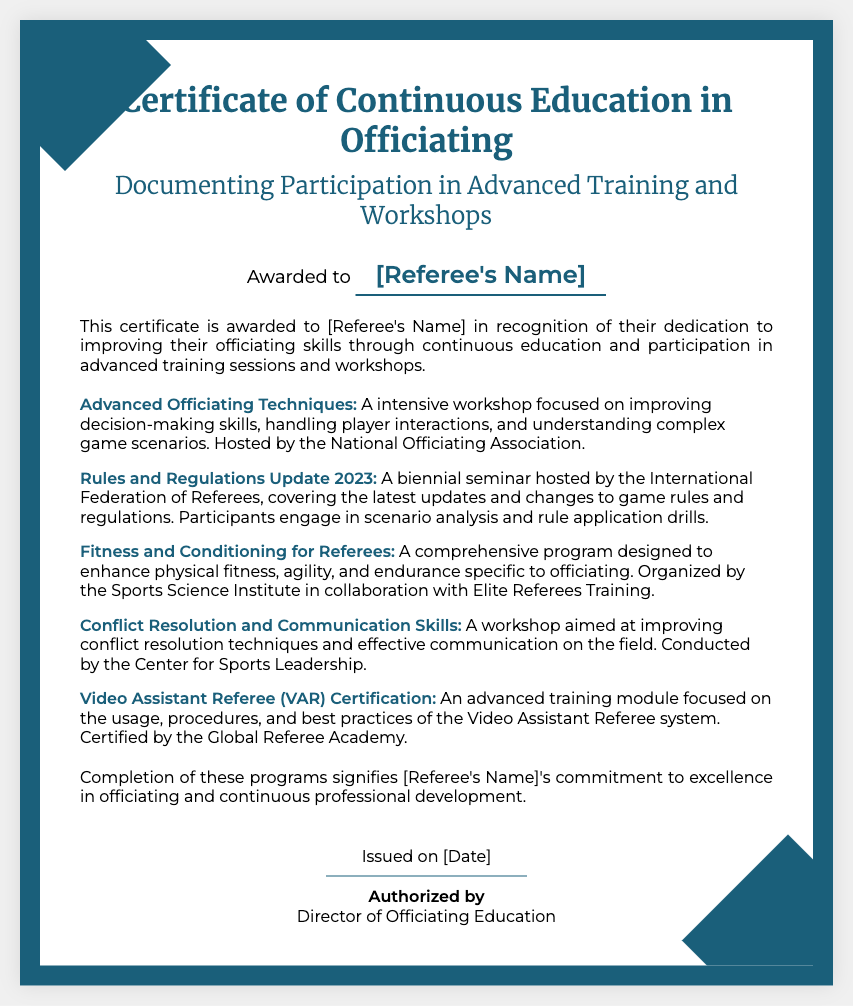What is the title of the certificate? The title of the certificate is located at the top of the document and states its purpose.
Answer: Certificate of Continuous Education in Officiating Who is the certificate awarded to? The name of the recipient is specifically highlighted in the document as a customizable field.
Answer: [Referee's Name] What is the first workshop listed in the document? The first workshop mentioned is detailed in the workshops section, focusing on officiating techniques.
Answer: Advanced Officiating Techniques What organization hosted the "Rules and Regulations Update 2023" seminar? The document specifies the host organization for this seminar in the description of the workshop.
Answer: International Federation of Referees What is the primary focus of the "Fitness and Conditioning for Referees" program? The document outlines the goal of this program in its description.
Answer: Enhance physical fitness What skills are improved in the "Conflict Resolution and Communication Skills" workshop? The workshop's description indicates the areas of skill enhancement provided in the training.
Answer: Conflict resolution techniques What does the completion of these programs signify? The conclusion section of the document states the importance of completing the programs for the referee's professional growth.
Answer: Commitment to excellence Who issued the certificate? The footer clearly indicates the authority responsible for issuing this certificate.
Answer: Director of Officiating Education On what date was the certificate issued? The certificate includes a customizable field for the issuance date, which reflects when it was awarded.
Answer: [Date] 